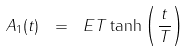<formula> <loc_0><loc_0><loc_500><loc_500>A _ { 1 } ( t ) \ = \ E T \tanh \left ( \frac { t } { T } \right )</formula> 